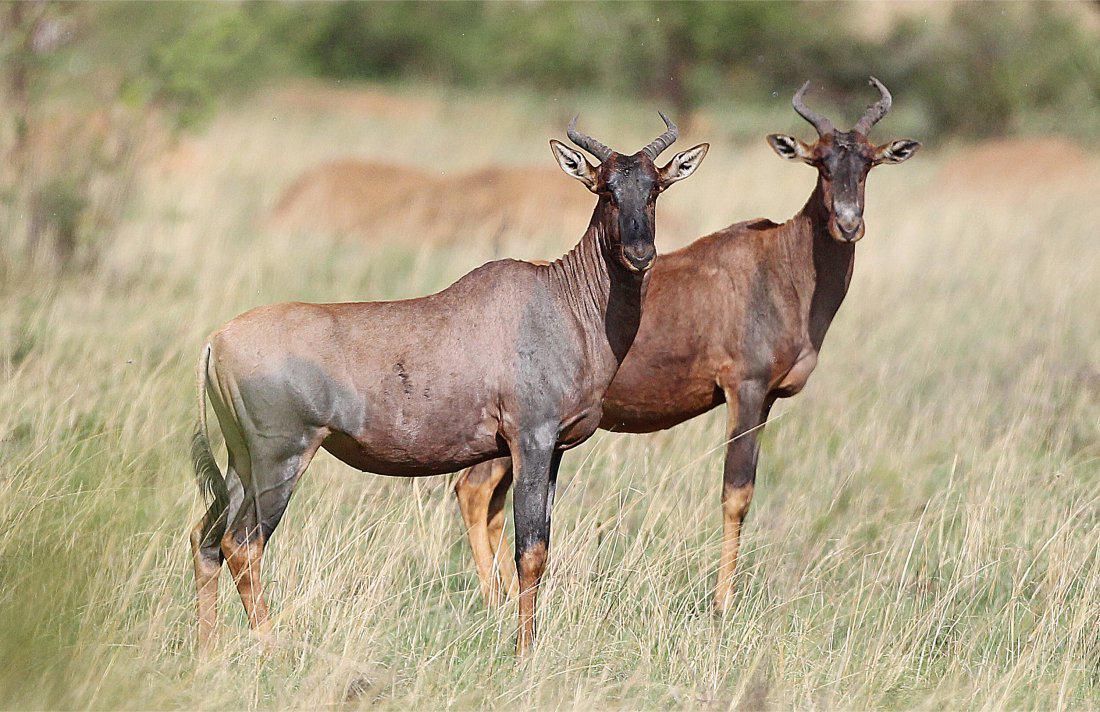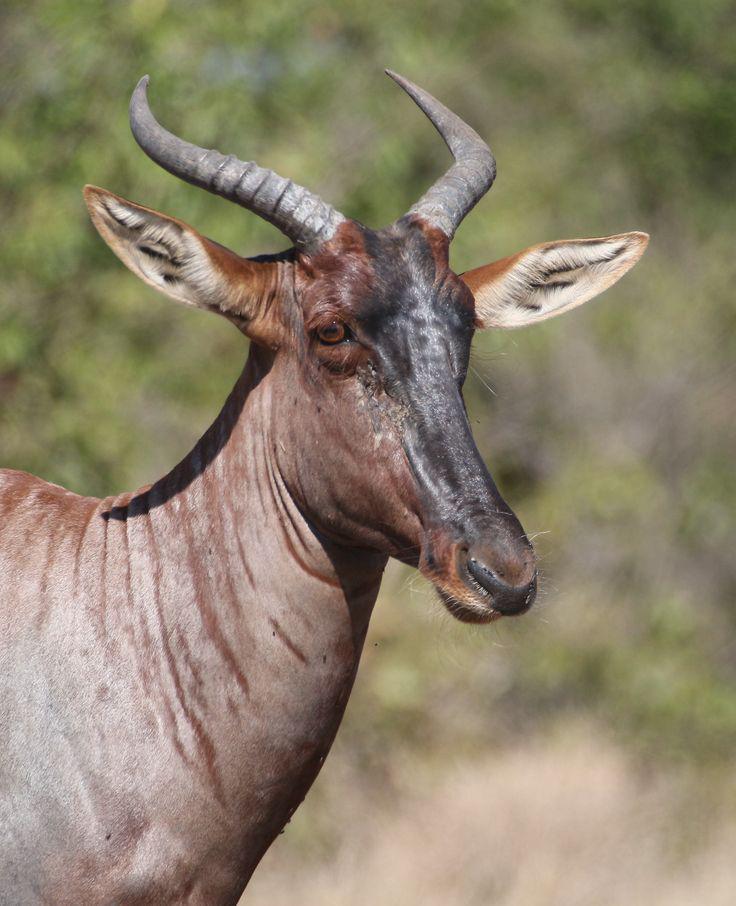The first image is the image on the left, the second image is the image on the right. Given the left and right images, does the statement "A young hooved animal without big horns stands facing right, in front of at least one big-horned animal." hold true? Answer yes or no. No. The first image is the image on the left, the second image is the image on the right. For the images displayed, is the sentence "There is no more than one antelope in the right image facing right." factually correct? Answer yes or no. Yes. 